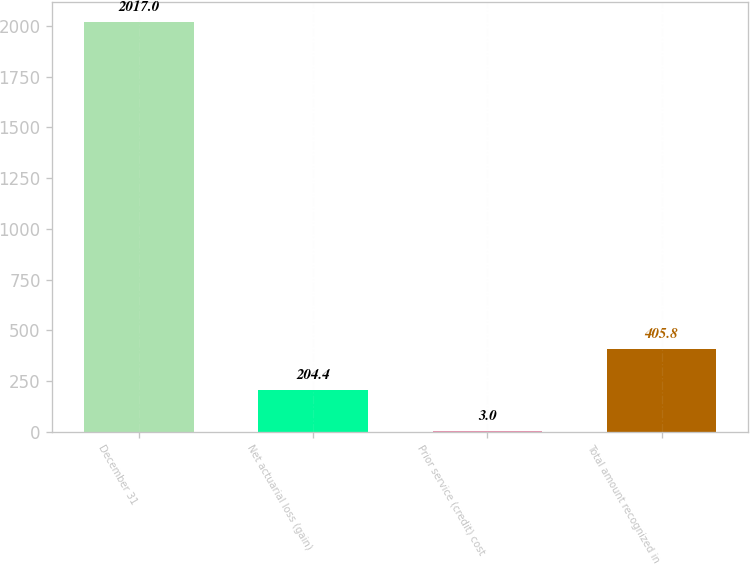<chart> <loc_0><loc_0><loc_500><loc_500><bar_chart><fcel>December 31<fcel>Net actuarial loss (gain)<fcel>Prior service (credit) cost<fcel>Total amount recognized in<nl><fcel>2017<fcel>204.4<fcel>3<fcel>405.8<nl></chart> 